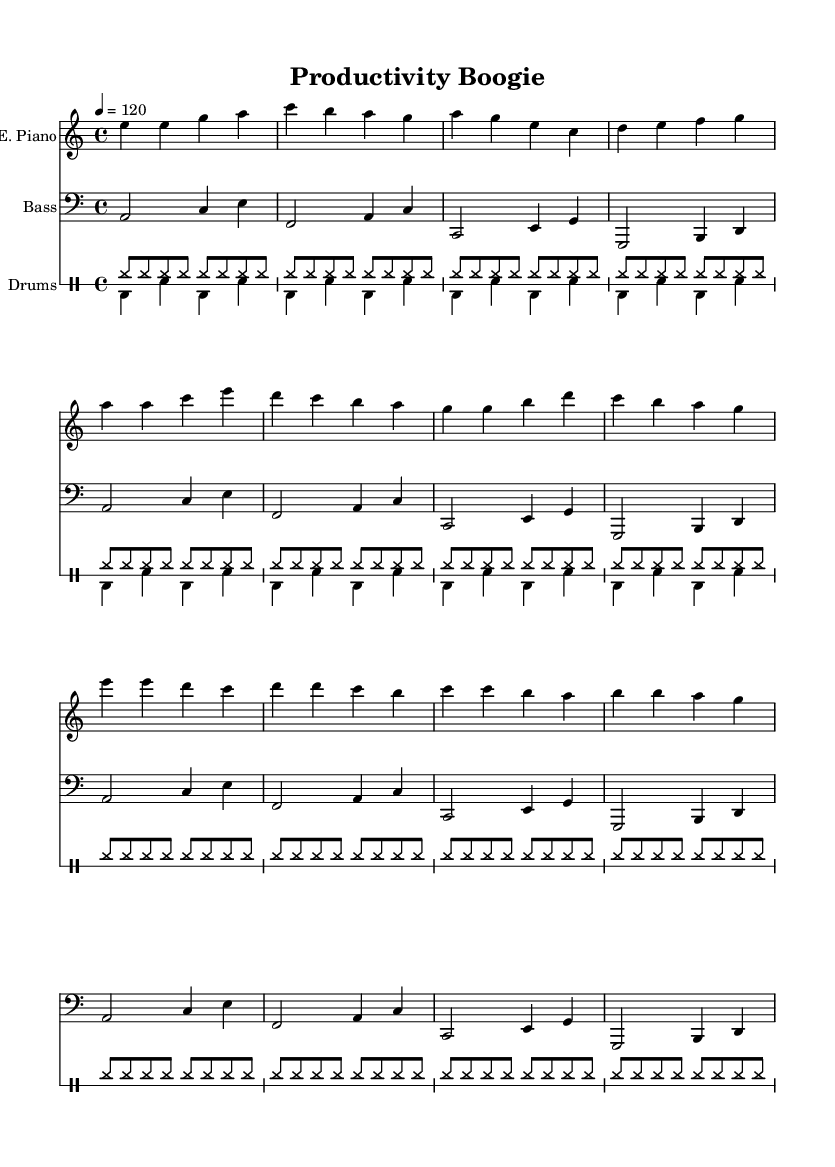What is the key signature of this music? The key signature for the piece is A minor, which typically has no sharps or flats, but is based on the relative C major scale with the same key signature, showing the music is in a minor tonality.
Answer: A minor What is the time signature of the piece? The time signature is indicated at the beginning of the score as 4/4, which means there are four beats in a measure, and each beat is a quarter note.
Answer: 4/4 What is the tempo marking? The tempo marking is given as 120 beats per minute (indicated by "4 = 120"), which means there should be 120 quarter note beats in one minute.
Answer: 120 How many measures are in the electric piano part? The electric piano part contains a total of 16 measures, as counted from the music notation provided, which includes the intro, verse, and chorus sections.
Answer: 16 What type of ensemble is being used in this piece? The ensemble consists of three parts: electric piano, bass guitar, and drums, indicating a typical disco band setup.
Answer: Trio How many times is the bass line repeated? The bass line is marked to repeat four times, as indicated by the "\repeat unfold 4" directive in the notation.
Answer: 4 What is the primary genre of this piece? The genre of the piece is disco, which is characterized by its upbeat tempo, danceable rhythms, and use of electronic instruments, as suggested by the instrumentation and style of the music.
Answer: Disco 